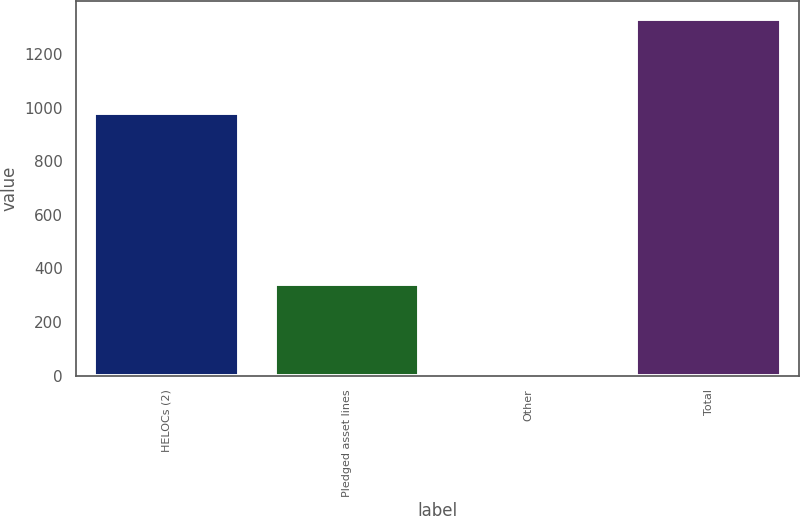Convert chart to OTSL. <chart><loc_0><loc_0><loc_500><loc_500><bar_chart><fcel>HELOCs (2)<fcel>Pledged asset lines<fcel>Other<fcel>Total<nl><fcel>980<fcel>341<fcel>10<fcel>1331<nl></chart> 